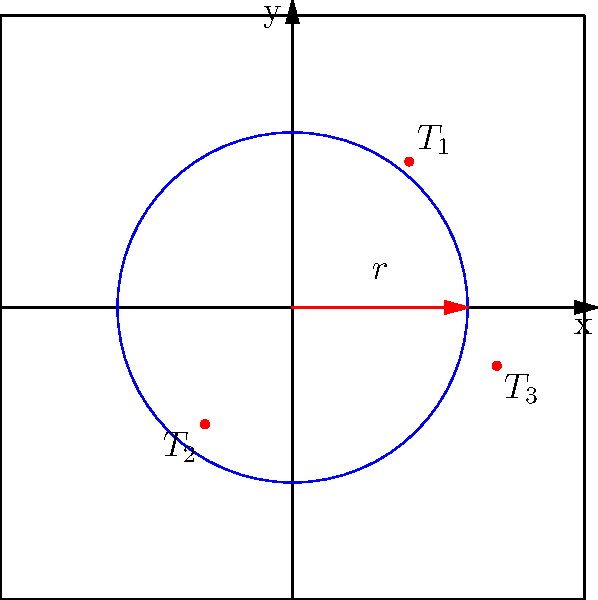As the head of security for a classified government facility, you need to establish a circular perimeter to protect against potential threats. Given three identified threat locations in polar coordinates: $T_1(3, 60°)$, $T_2(2.5, 230°)$, and $T_3(3.6, 345°)$, what is the minimum radius $r$ (rounded to one decimal place) required for the security perimeter to encompass all threat points? To find the minimum radius that encompasses all threat points, we need to:

1. Convert the polar coordinates $(r, \theta)$ to Cartesian coordinates $(x, y)$ using:
   $x = r \cos(\theta)$
   $y = r \sin(\theta)$

2. For $T_1(3, 60°)$:
   $x_1 = 3 \cos(60°) = 1.5$
   $y_1 = 3 \sin(60°) = 2.6$

3. For $T_2(2.5, 230°)$:
   $x_2 = 2.5 \cos(230°) = -1.6$
   $y_2 = 2.5 \sin(230°) = -1.9$

4. For $T_3(3.6, 345°)$:
   $x_3 = 3.6 \cos(345°) = 3.5$
   $y_3 = 3.6 \sin(345°) = -0.9$

5. Calculate the distance from the origin to each point using the distance formula:
   $d = \sqrt{x^2 + y^2}$

6. For $T_1$: $d_1 = \sqrt{1.5^2 + 2.6^2} = 3$
   For $T_2$: $d_2 = \sqrt{(-1.6)^2 + (-1.9)^2} = 2.5$
   For $T_3$: $d_3 = \sqrt{3.5^2 + (-0.9)^2} = 3.6$

7. The minimum radius required is the maximum of these distances: $max(3, 2.5, 3.6) = 3.6$

8. Rounding to one decimal place: $3.6$
Answer: $3.6$ 